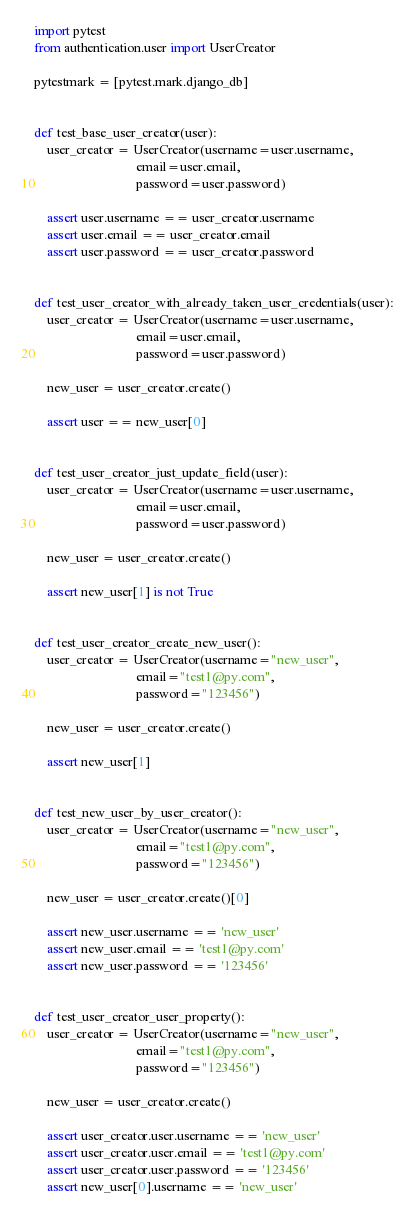Convert code to text. <code><loc_0><loc_0><loc_500><loc_500><_Python_>import pytest
from authentication.user import UserCreator

pytestmark = [pytest.mark.django_db]


def test_base_user_creator(user):
    user_creator = UserCreator(username=user.username,
                               email=user.email,
                               password=user.password)

    assert user.username == user_creator.username
    assert user.email == user_creator.email
    assert user.password == user_creator.password


def test_user_creator_with_already_taken_user_credentials(user):
    user_creator = UserCreator(username=user.username,
                               email=user.email,
                               password=user.password)

    new_user = user_creator.create()

    assert user == new_user[0]


def test_user_creator_just_update_field(user):
    user_creator = UserCreator(username=user.username,
                               email=user.email,
                               password=user.password)

    new_user = user_creator.create()

    assert new_user[1] is not True


def test_user_creator_create_new_user():
    user_creator = UserCreator(username="new_user",
                               email="test1@py.com",
                               password="123456")

    new_user = user_creator.create()

    assert new_user[1]


def test_new_user_by_user_creator():
    user_creator = UserCreator(username="new_user",
                               email="test1@py.com",
                               password="123456")

    new_user = user_creator.create()[0]

    assert new_user.username == 'new_user'
    assert new_user.email == 'test1@py.com'
    assert new_user.password == '123456'


def test_user_creator_user_property():
    user_creator = UserCreator(username="new_user",
                               email="test1@py.com",
                               password="123456")

    new_user = user_creator.create()

    assert user_creator.user.username == 'new_user'
    assert user_creator.user.email == 'test1@py.com'
    assert user_creator.user.password == '123456'
    assert new_user[0].username == 'new_user'
</code> 